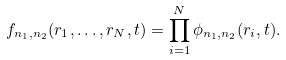Convert formula to latex. <formula><loc_0><loc_0><loc_500><loc_500>f _ { n _ { 1 } , n _ { 2 } } ( { r } _ { 1 } , \dots , { r } _ { N } , t ) = \prod _ { i = 1 } ^ { N } \phi _ { n _ { 1 } , n _ { 2 } } ( { r } _ { i } , t ) .</formula> 